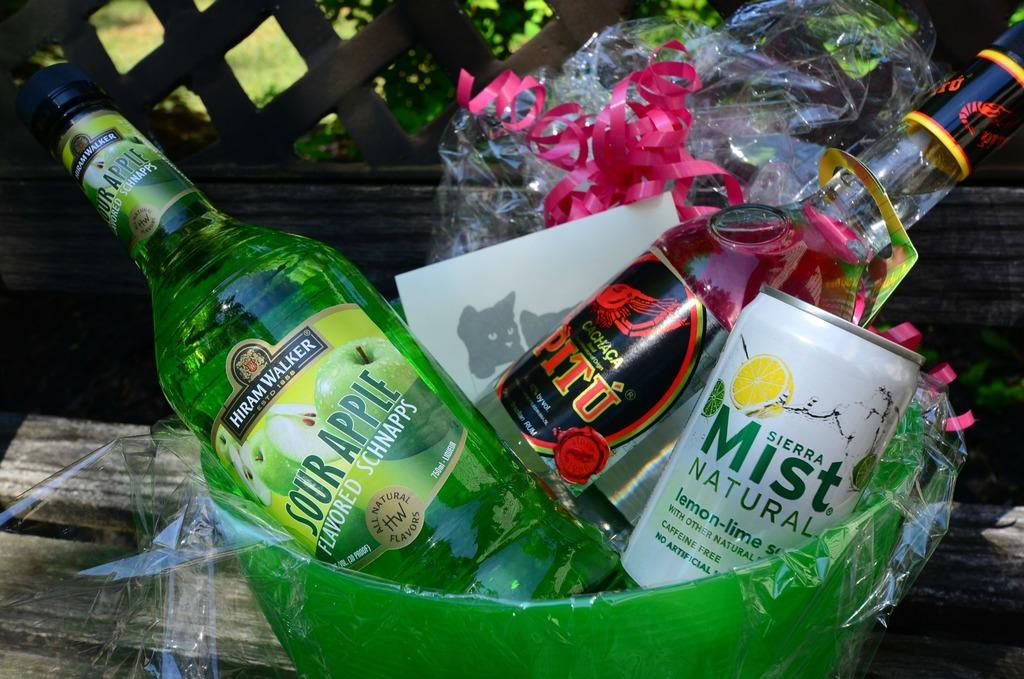<image>
Provide a brief description of the given image. green gift bowl with can of sierra mist soda, bottles of sour apple schnapps and cachaca pitu 